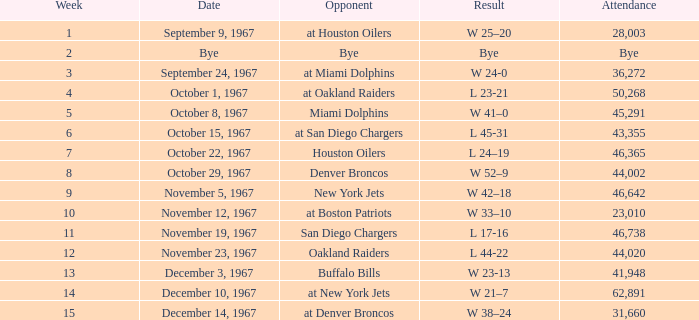Which week was the game on December 14, 1967? 15.0. 